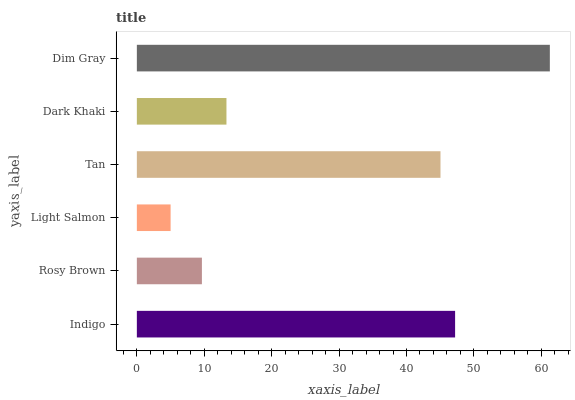Is Light Salmon the minimum?
Answer yes or no. Yes. Is Dim Gray the maximum?
Answer yes or no. Yes. Is Rosy Brown the minimum?
Answer yes or no. No. Is Rosy Brown the maximum?
Answer yes or no. No. Is Indigo greater than Rosy Brown?
Answer yes or no. Yes. Is Rosy Brown less than Indigo?
Answer yes or no. Yes. Is Rosy Brown greater than Indigo?
Answer yes or no. No. Is Indigo less than Rosy Brown?
Answer yes or no. No. Is Tan the high median?
Answer yes or no. Yes. Is Dark Khaki the low median?
Answer yes or no. Yes. Is Dark Khaki the high median?
Answer yes or no. No. Is Indigo the low median?
Answer yes or no. No. 